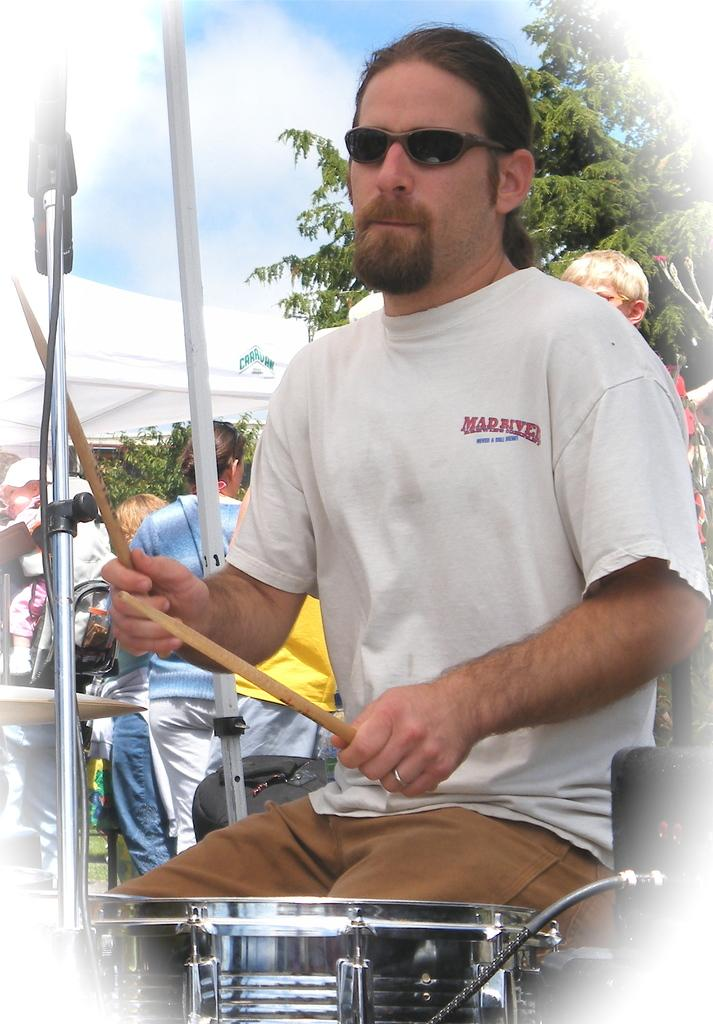What is the man in the image doing? The man is playing drums. What is the man wearing while playing drums? The man is wearing goggles. What can be seen in the background of the image? There is a sky and a tree visible in the background of the image. What type of quilt is being used as a drum cover in the image? There is no quilt present in the image, and the drums do not have a cover. 